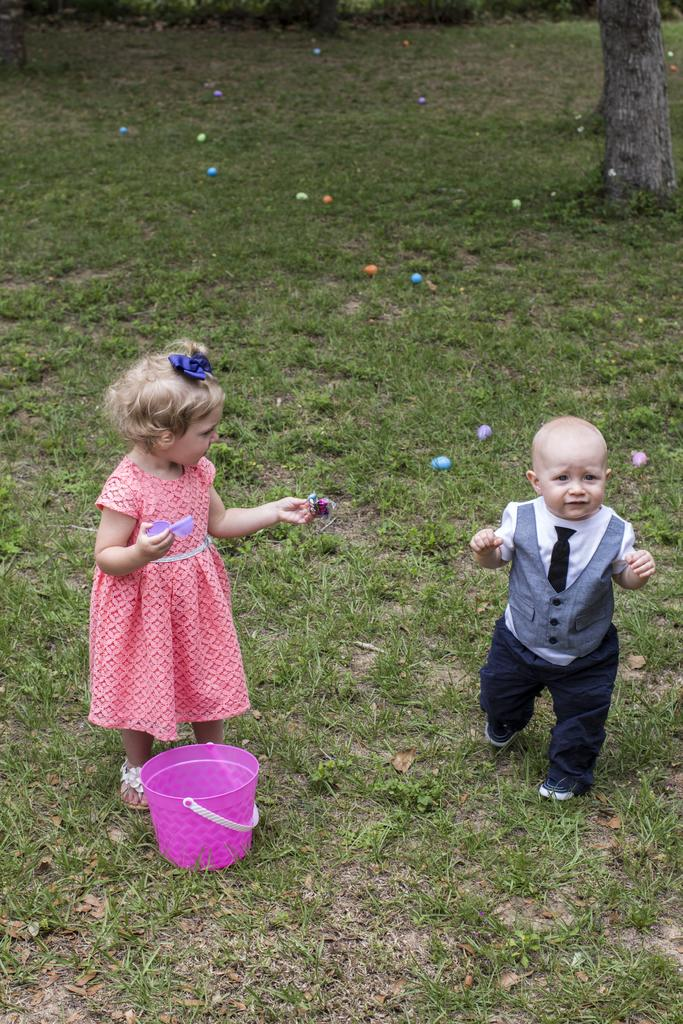How many kids are present in the image? There are two kids on the ground in the image. What is the surface they are sitting on? The ground is covered with grass. What objects can be seen in the image besides the kids? There are balls and a bucket in the image. What color is the stocking on the ladybug in the image? There is no ladybug or stocking present in the image; it features two kids, grass-covered ground, balls, and a bucket. 